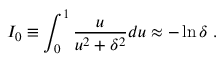Convert formula to latex. <formula><loc_0><loc_0><loc_500><loc_500>I _ { 0 } \equiv \int _ { 0 } ^ { 1 } \frac { u } { u ^ { 2 } + \delta ^ { 2 } } d u \approx - \ln \delta \, .</formula> 